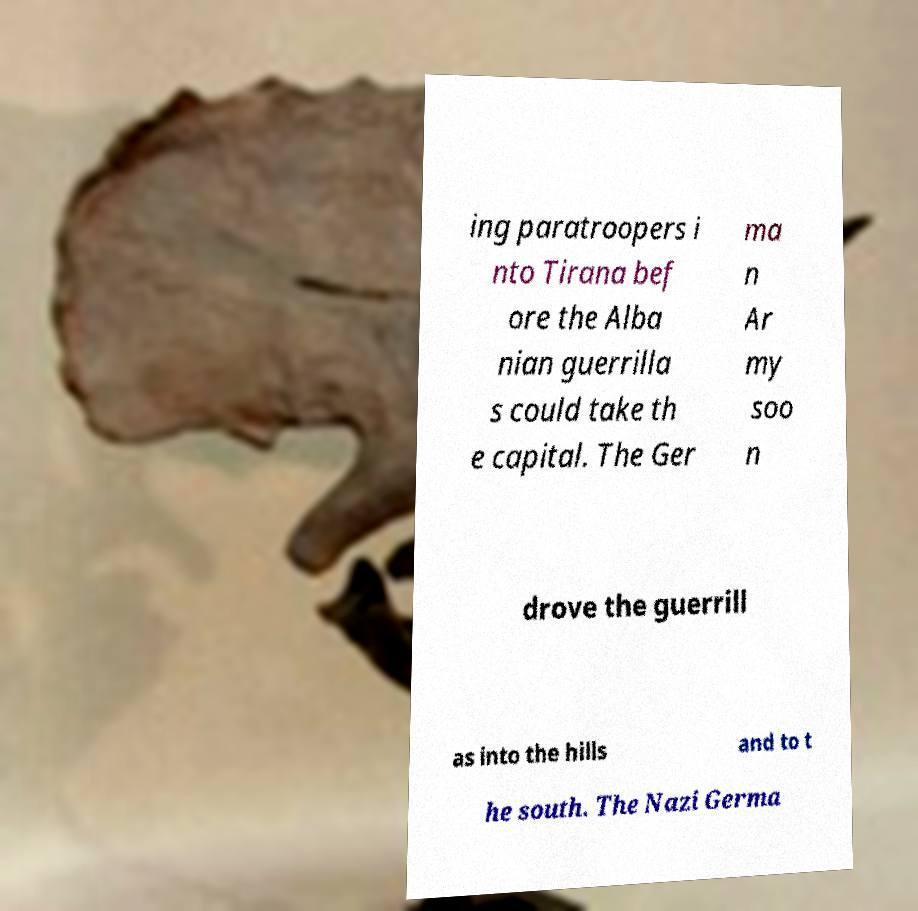Can you accurately transcribe the text from the provided image for me? ing paratroopers i nto Tirana bef ore the Alba nian guerrilla s could take th e capital. The Ger ma n Ar my soo n drove the guerrill as into the hills and to t he south. The Nazi Germa 